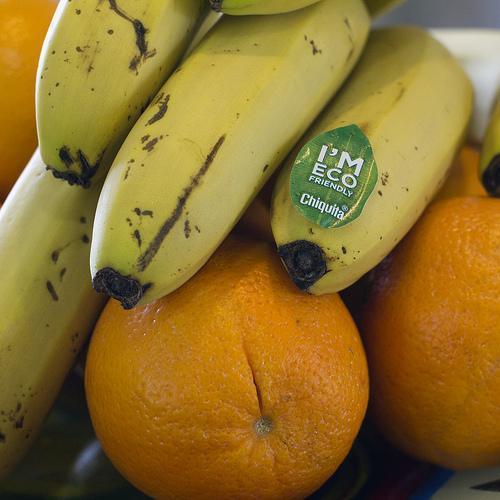How many bananas are in the picture?
Give a very brief answer. 6. 